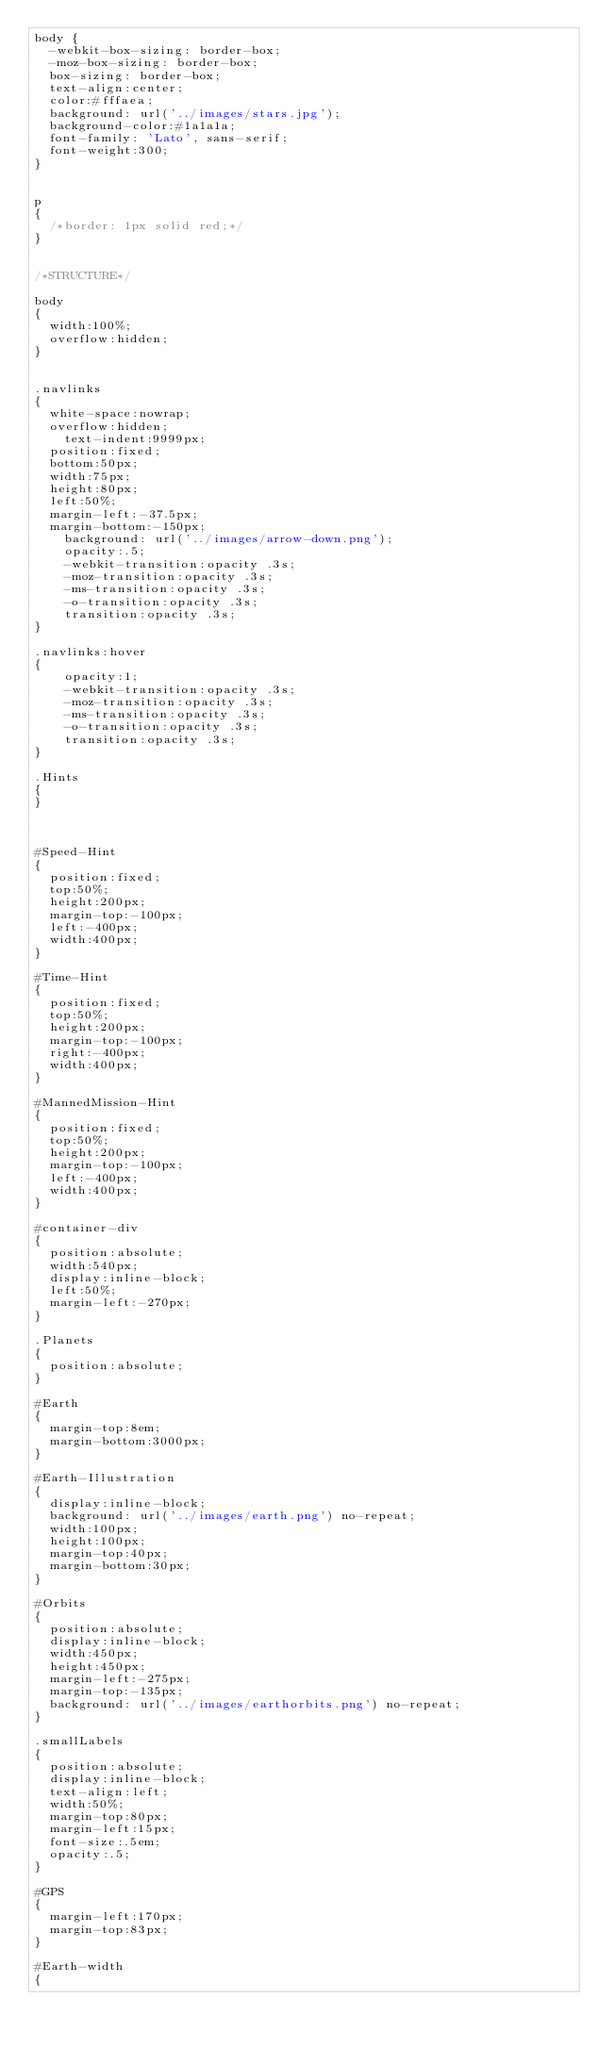<code> <loc_0><loc_0><loc_500><loc_500><_CSS_>body {
	-webkit-box-sizing: border-box;
	-moz-box-sizing: border-box;
	box-sizing: border-box;
	text-align:center;
	color:#fffaea;
	background: url('../images/stars.jpg');
	background-color:#1a1a1a;
	font-family: 'Lato', sans-serif;
	font-weight:300;
}


p
{
	/*border: 1px solid red;*/
}


/*STRUCTURE*/

body
{
	width:100%;
	overflow:hidden;
}


.navlinks
{
	white-space:nowrap;
	overflow:hidden;
    text-indent:9999px;
	position:fixed;
	bottom:50px;
	width:75px;
	height:80px;
	left:50%;
	margin-left:-37.5px;
	margin-bottom:-150px;
    background: url('../images/arrow-down.png');
    opacity:.5;
   	-webkit-transition:opacity .3s;
   	-moz-transition:opacity .3s;
   	-ms-transition:opacity .3s;
   	-o-transition:opacity .3s;
   	transition:opacity .3s;
}

.navlinks:hover
{
    opacity:1;
   	-webkit-transition:opacity .3s;
   	-moz-transition:opacity .3s;
   	-ms-transition:opacity .3s;
   	-o-transition:opacity .3s;
   	transition:opacity .3s;
}

.Hints
{
}



#Speed-Hint
{
	position:fixed;
	top:50%;
	height:200px;
	margin-top:-100px;
	left:-400px;
	width:400px;
}

#Time-Hint
{
	position:fixed;
	top:50%;
	height:200px;
	margin-top:-100px;
	right:-400px;
	width:400px;
}

#MannedMission-Hint
{
	position:fixed;
	top:50%;
	height:200px;
	margin-top:-100px;
	left:-400px;
	width:400px;
}

#container-div
{
	position:absolute;
	width:540px;	
	display:inline-block;
	left:50%;
	margin-left:-270px;
}

.Planets
{
	position:absolute;
}

#Earth
{
	margin-top:8em;
	margin-bottom:3000px;
}

#Earth-Illustration
{
	display:inline-block;
	background: url('../images/earth.png') no-repeat;
	width:100px;
	height:100px;
	margin-top:40px;
	margin-bottom:30px;
}

#Orbits
{
	position:absolute;
	display:inline-block;
	width:450px;
	height:450px;
	margin-left:-275px;
	margin-top:-135px;
	background: url('../images/earthorbits.png') no-repeat;
}

.smallLabels
{
	position:absolute;
	display:inline-block;
	text-align:left;
	width:50%;
	margin-top:80px;
	margin-left:15px;
	font-size:.5em;
	opacity:.5;
}

#GPS
{
	margin-left:170px;
	margin-top:83px;
}

#Earth-width
{</code> 